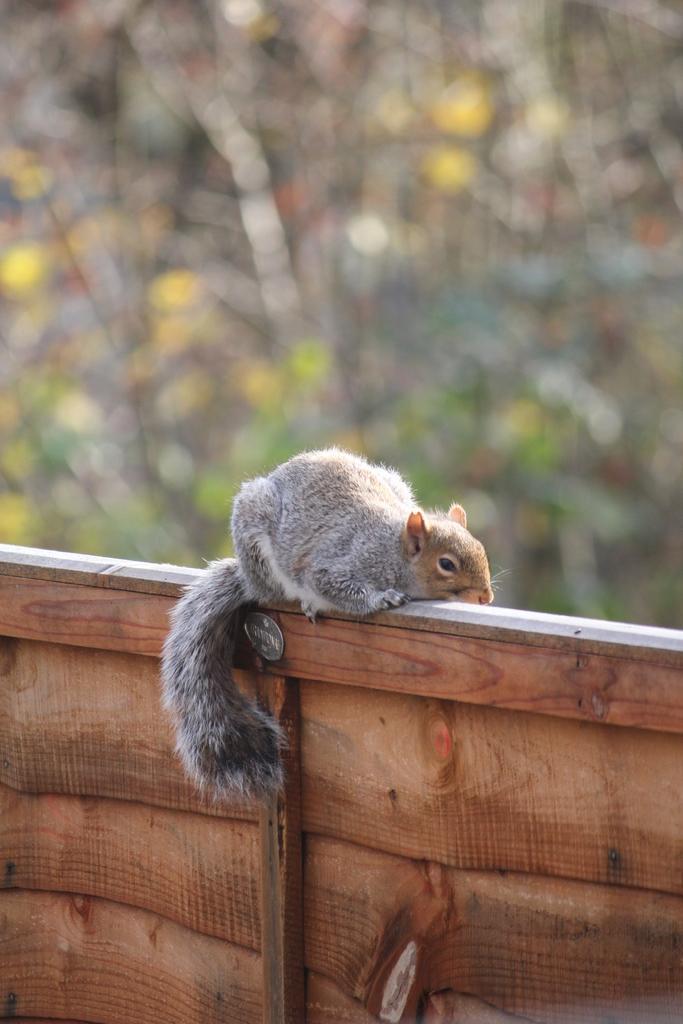Could you give a brief overview of what you see in this image? In this image I can see a squirrel which is white, ash and brown in color is on the wooden wall. In the background I can see few trees which are blurred. 